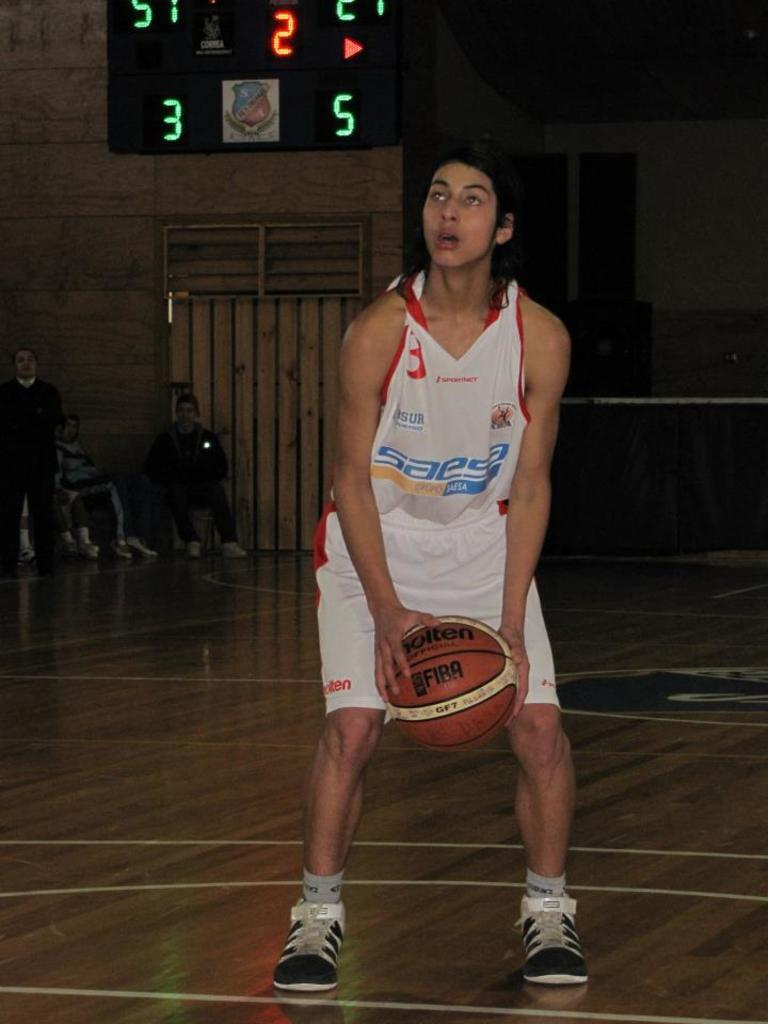<image>
Relay a brief, clear account of the picture shown. a person with a basketball that has the word Fiba on it 